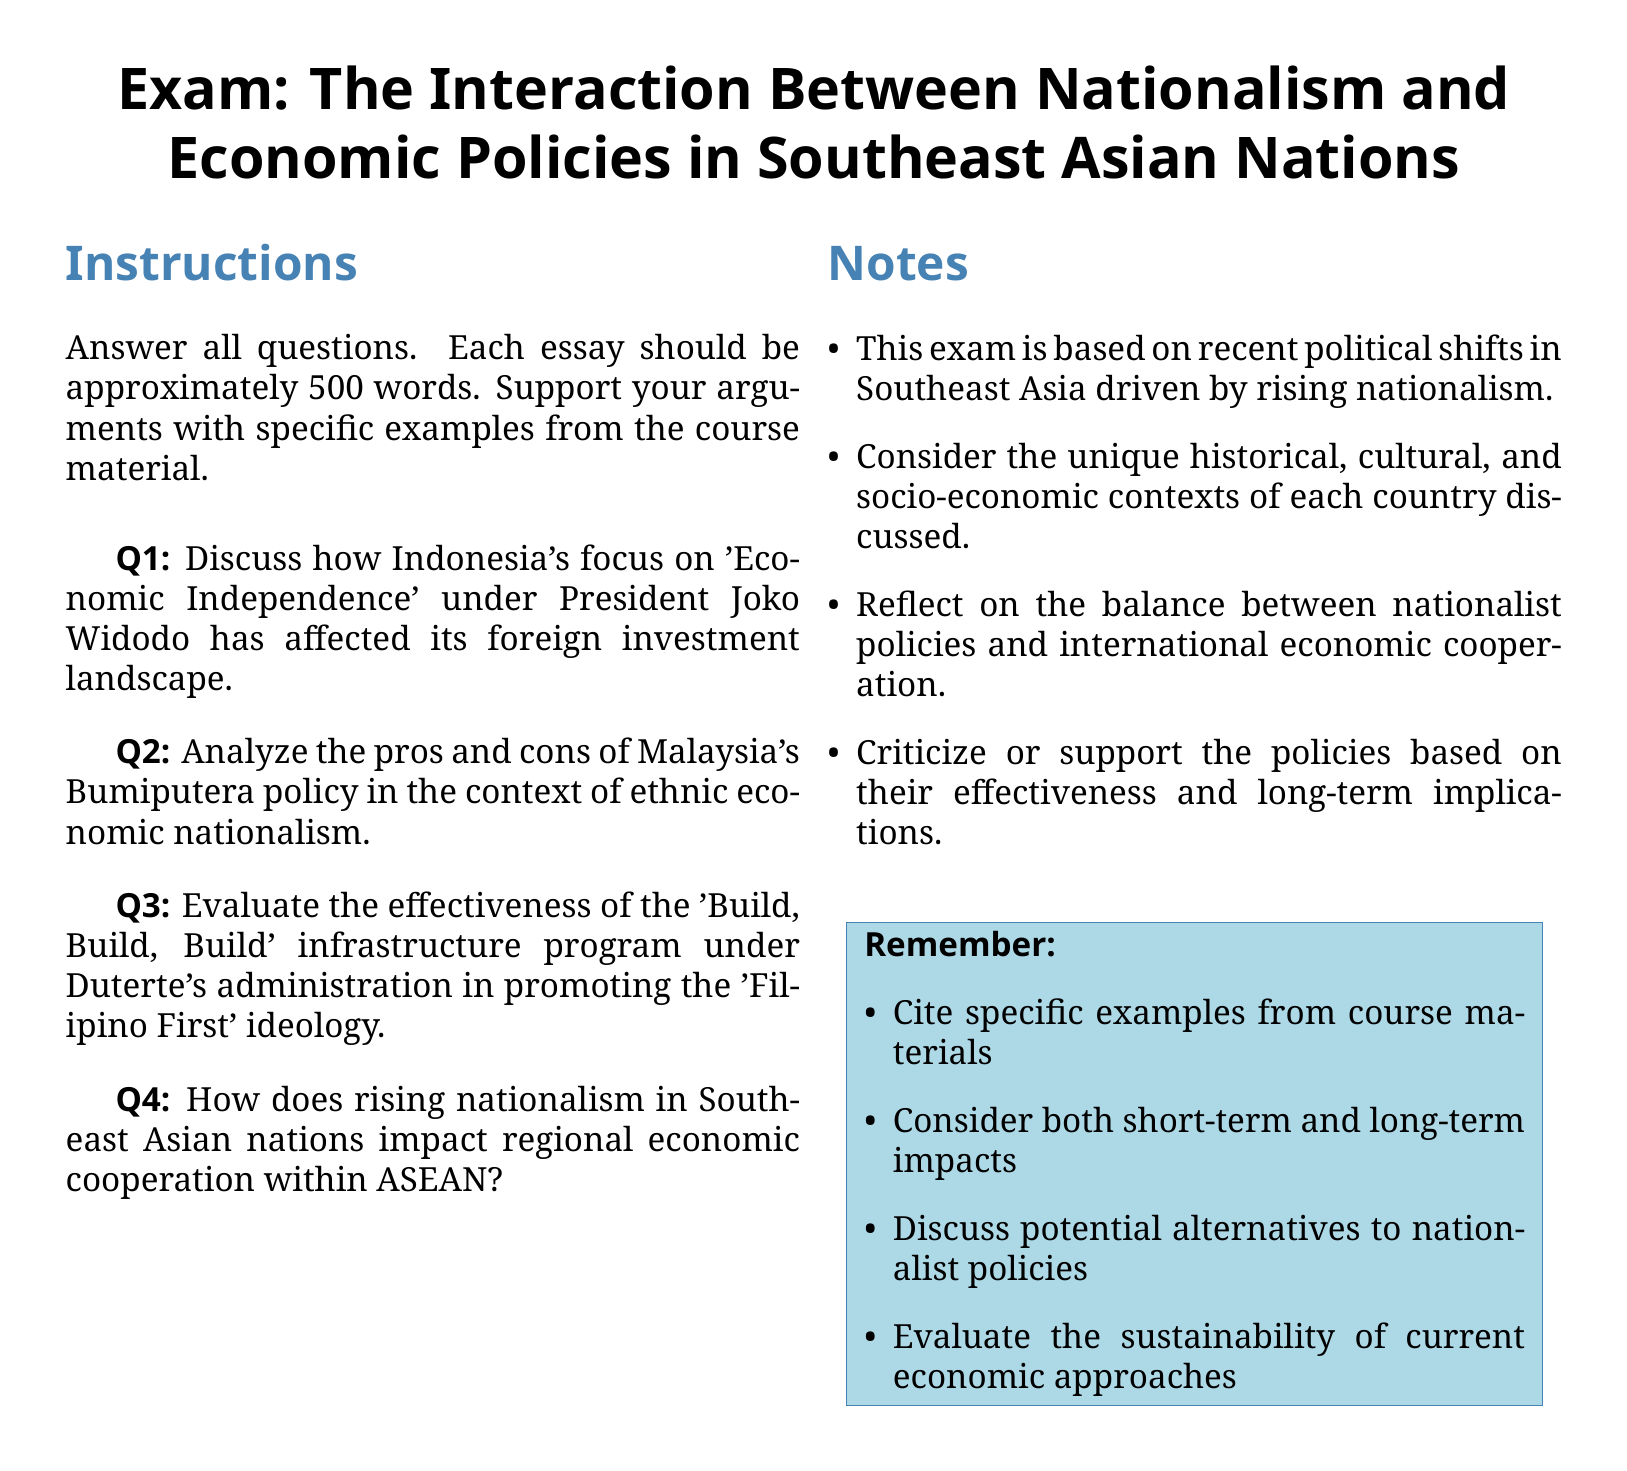What is the title of the exam? The title of the exam is clearly stated at the top of the document as "Exam: The Interaction Between Nationalism and Economic Policies in Southeast Asian Nations."
Answer: Exam: The Interaction Between Nationalism and Economic Policies in Southeast Asian Nations How many questions are there in the exam? The exam contains four questions, which are listed sequentially under exam questions.
Answer: 4 Who is the president mentioned in relation to Indonesia's economic policies? The document mentions President Joko Widodo in the context of Indonesia's focus on economic independence.
Answer: Joko Widodo What is the focus of Malaysia's Bumiputera policy? The document refers to Malaysia's Bumiputera policy in the context of ethnic economic nationalism.
Answer: Ethnic economic nationalism What is the duration suggested for each essay response? The instructions specify that each essay should be approximately 500 words.
Answer: 500 words What is the primary ideology promoted by Duterte's 'Build, Build, Build' program? The program is evaluated based on its effectiveness in promoting the 'Filipino First' ideology as indicated in the exam questions.
Answer: Filipino First What type of impact does rising nationalism have according to the last question? The last question asks about the impact of rising nationalism on regional economic cooperation within ASEAN, indicating a broader regional effect.
Answer: Regional economic cooperation What should students include in their answers according to the notes section? Students are advised to cite specific examples from course materials, which emphasizes the need for evidence in their essays.
Answer: Specific examples from course materials 